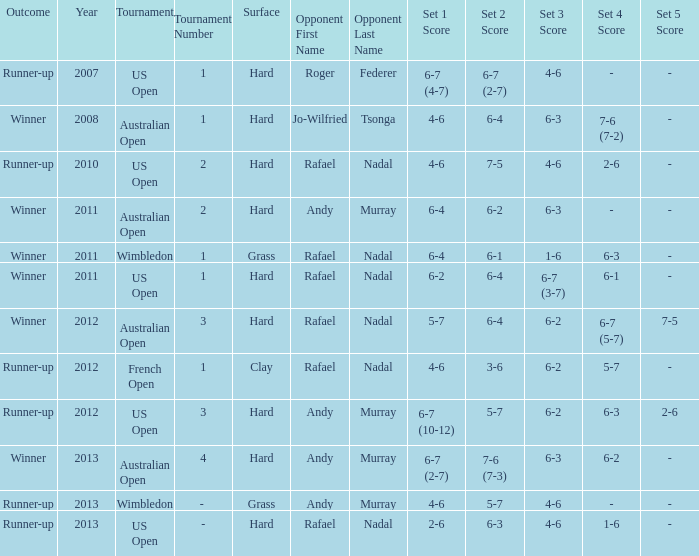What is the outcome of the match with Roger Federer as the opponent? Runner-up. 